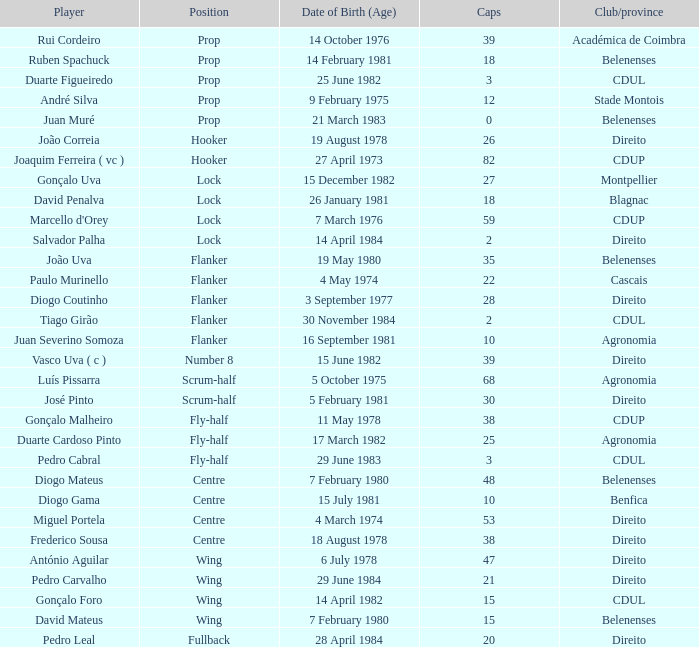Write the full table. {'header': ['Player', 'Position', 'Date of Birth (Age)', 'Caps', 'Club/province'], 'rows': [['Rui Cordeiro', 'Prop', '14 October 1976', '39', 'Académica de Coimbra'], ['Ruben Spachuck', 'Prop', '14 February 1981', '18', 'Belenenses'], ['Duarte Figueiredo', 'Prop', '25 June 1982', '3', 'CDUL'], ['André Silva', 'Prop', '9 February 1975', '12', 'Stade Montois'], ['Juan Muré', 'Prop', '21 March 1983', '0', 'Belenenses'], ['João Correia', 'Hooker', '19 August 1978', '26', 'Direito'], ['Joaquim Ferreira ( vc )', 'Hooker', '27 April 1973', '82', 'CDUP'], ['Gonçalo Uva', 'Lock', '15 December 1982', '27', 'Montpellier'], ['David Penalva', 'Lock', '26 January 1981', '18', 'Blagnac'], ["Marcello d'Orey", 'Lock', '7 March 1976', '59', 'CDUP'], ['Salvador Palha', 'Lock', '14 April 1984', '2', 'Direito'], ['João Uva', 'Flanker', '19 May 1980', '35', 'Belenenses'], ['Paulo Murinello', 'Flanker', '4 May 1974', '22', 'Cascais'], ['Diogo Coutinho', 'Flanker', '3 September 1977', '28', 'Direito'], ['Tiago Girão', 'Flanker', '30 November 1984', '2', 'CDUL'], ['Juan Severino Somoza', 'Flanker', '16 September 1981', '10', 'Agronomia'], ['Vasco Uva ( c )', 'Number 8', '15 June 1982', '39', 'Direito'], ['Luís Pissarra', 'Scrum-half', '5 October 1975', '68', 'Agronomia'], ['José Pinto', 'Scrum-half', '5 February 1981', '30', 'Direito'], ['Gonçalo Malheiro', 'Fly-half', '11 May 1978', '38', 'CDUP'], ['Duarte Cardoso Pinto', 'Fly-half', '17 March 1982', '25', 'Agronomia'], ['Pedro Cabral', 'Fly-half', '29 June 1983', '3', 'CDUL'], ['Diogo Mateus', 'Centre', '7 February 1980', '48', 'Belenenses'], ['Diogo Gama', 'Centre', '15 July 1981', '10', 'Benfica'], ['Miguel Portela', 'Centre', '4 March 1974', '53', 'Direito'], ['Frederico Sousa', 'Centre', '18 August 1978', '38', 'Direito'], ['António Aguilar', 'Wing', '6 July 1978', '47', 'Direito'], ['Pedro Carvalho', 'Wing', '29 June 1984', '21', 'Direito'], ['Gonçalo Foro', 'Wing', '14 April 1982', '15', 'CDUL'], ['David Mateus', 'Wing', '7 February 1980', '15', 'Belenenses'], ['Pedro Leal', 'Fullback', '28 April 1984', '20', 'Direito']]} Which player has a Club/province of direito, less than 21 caps, and a Position of lock? Salvador Palha. 